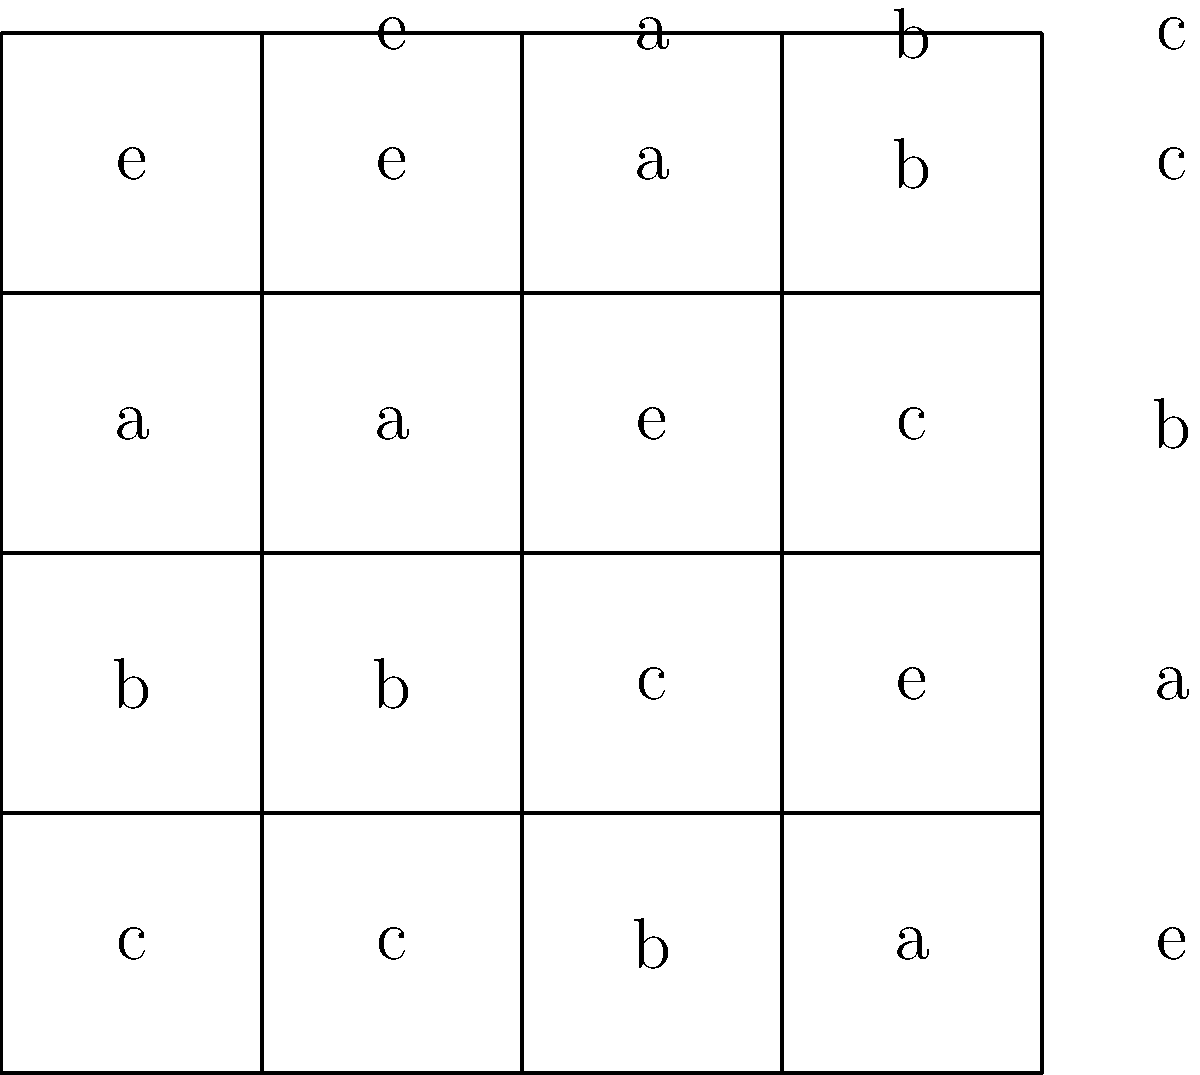Given the Cayley table for a group of order 4 shown above, determine which of the following statements is true:

a) The group is cyclic
b) The group is abelian
c) The group is isomorphic to $\mathbb{Z}_4$
d) The group is isomorphic to $\mathbb{Z}_2 \times \mathbb{Z}_2$ Let's analyze the Cayley table step by step:

1) First, we observe that the group has 4 elements: e, a, b, and c.

2) We can see that e is the identity element, as e * x = x * e = x for all x in the group.

3) Every element has an inverse:
   a * a = e, b * b = e, c * c = e

4) The group operation is associative (this is always true for a valid Cayley table).

5) To determine if the group is abelian, we check if x * y = y * x for all x, y:
   a * b = c = b * a
   a * c = b = c * a
   b * c = a = c * b
   Therefore, the group is abelian.

6) To determine if the group is cyclic, we check if any element generates the whole group:
   e generates only {e}
   a generates {e, a}
   b generates {e, b}
   c generates {e, c}
   No element generates the whole group, so it's not cyclic.

7) Since the group is not cyclic, it cannot be isomorphic to $\mathbb{Z}_4$.

8) The structure of this group matches $\mathbb{Z}_2 \times \mathbb{Z}_2$:
   - It's abelian
   - It has order 4
   - Every non-identity element has order 2

Therefore, the correct statement is d) The group is isomorphic to $\mathbb{Z}_2 \times \mathbb{Z}_2$.
Answer: d) The group is isomorphic to $\mathbb{Z}_2 \times \mathbb{Z}_2$ 